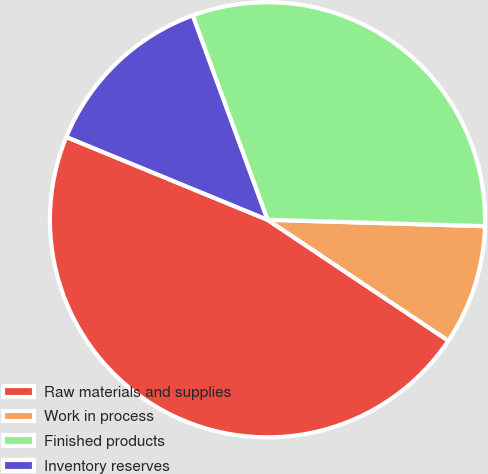Convert chart. <chart><loc_0><loc_0><loc_500><loc_500><pie_chart><fcel>Raw materials and supplies<fcel>Work in process<fcel>Finished products<fcel>Inventory reserves<nl><fcel>46.84%<fcel>8.91%<fcel>31.06%<fcel>13.2%<nl></chart> 